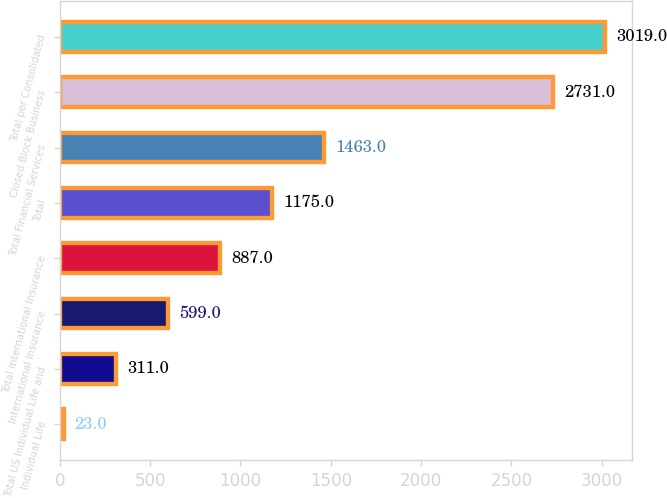Convert chart to OTSL. <chart><loc_0><loc_0><loc_500><loc_500><bar_chart><fcel>Individual Life<fcel>Total US Individual Life and<fcel>International Insurance<fcel>Total International Insurance<fcel>Total<fcel>Total Financial Services<fcel>Closed Block Business<fcel>Total per Consolidated<nl><fcel>23<fcel>311<fcel>599<fcel>887<fcel>1175<fcel>1463<fcel>2731<fcel>3019<nl></chart> 